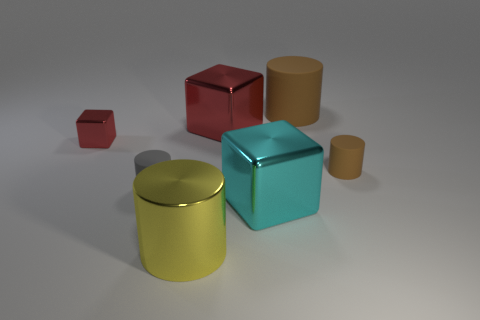What size is the other block that is the same color as the small metal block?
Keep it short and to the point. Large. Is there a object of the same color as the big matte cylinder?
Keep it short and to the point. Yes. How many large blocks are in front of the tiny red shiny block?
Offer a terse response. 1. Is the material of the cylinder behind the large red shiny object the same as the big yellow cylinder?
Provide a short and direct response. No. What color is the other tiny metal object that is the same shape as the cyan thing?
Provide a short and direct response. Red. What shape is the small brown rubber object?
Your answer should be very brief. Cylinder. How many objects are tiny shiny objects or shiny cylinders?
Offer a terse response. 2. Is the color of the tiny rubber cylinder that is to the right of the yellow metallic cylinder the same as the big cylinder that is behind the gray rubber object?
Provide a succinct answer. Yes. How many other objects are there of the same shape as the gray thing?
Ensure brevity in your answer.  3. Are any big shiny objects visible?
Your response must be concise. Yes. 